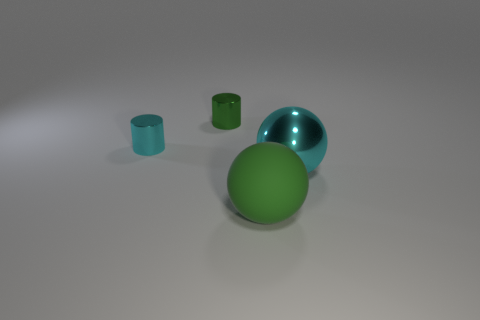Subtract 1 balls. How many balls are left? 1 Add 3 big cyan objects. How many objects exist? 7 Add 2 cyan shiny objects. How many cyan shiny objects exist? 4 Subtract all green cylinders. How many cylinders are left? 1 Subtract 0 purple spheres. How many objects are left? 4 Subtract all red balls. Subtract all gray cubes. How many balls are left? 2 Subtract all green balls. How many blue cylinders are left? 0 Subtract all large cyan metallic things. Subtract all big metallic balls. How many objects are left? 2 Add 3 green things. How many green things are left? 5 